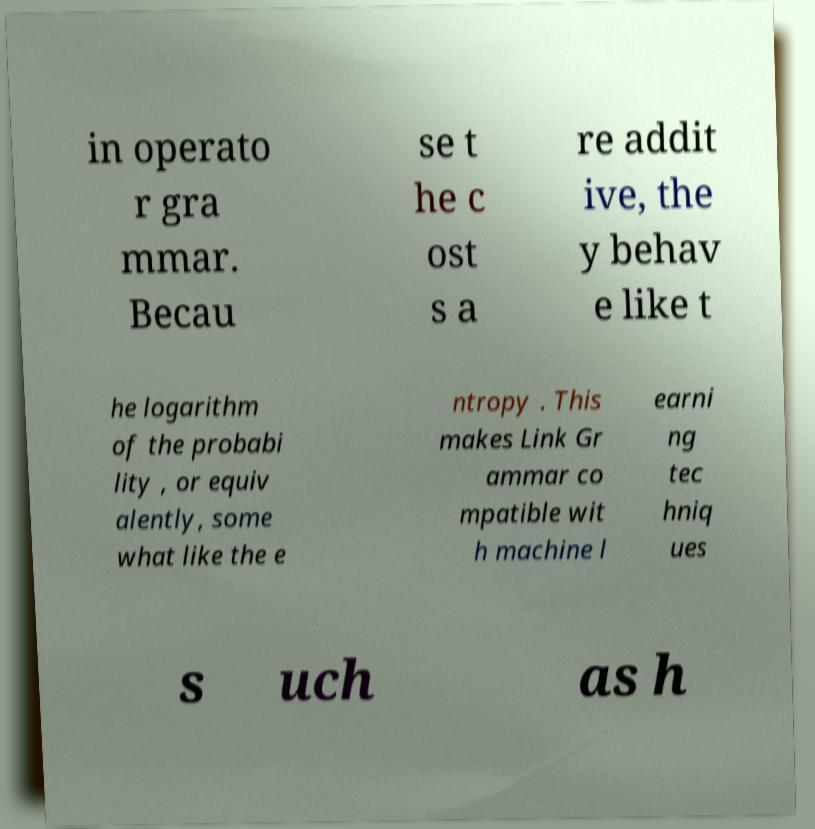I need the written content from this picture converted into text. Can you do that? in operato r gra mmar. Becau se t he c ost s a re addit ive, the y behav e like t he logarithm of the probabi lity , or equiv alently, some what like the e ntropy . This makes Link Gr ammar co mpatible wit h machine l earni ng tec hniq ues s uch as h 